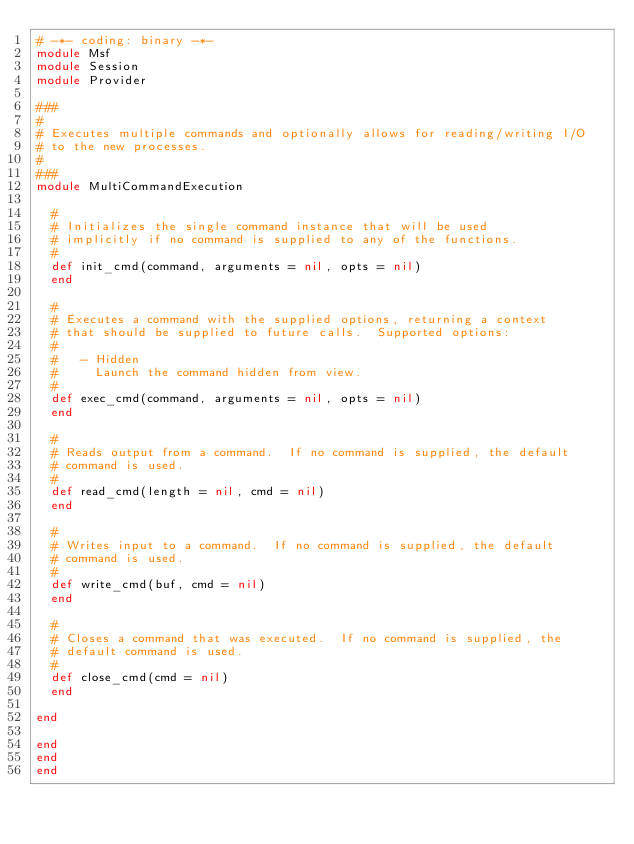<code> <loc_0><loc_0><loc_500><loc_500><_Ruby_># -*- coding: binary -*-
module Msf
module Session
module Provider

###
#
# Executes multiple commands and optionally allows for reading/writing I/O
# to the new processes.
#
###
module MultiCommandExecution

  #
  # Initializes the single command instance that will be used
  # implicitly if no command is supplied to any of the functions.
  #
  def init_cmd(command, arguments = nil, opts = nil)
  end

  #
  # Executes a command with the supplied options, returning a context
  # that should be supplied to future calls.  Supported options:
  #
  #   - Hidden
  #     Launch the command hidden from view.
  #
  def exec_cmd(command, arguments = nil, opts = nil)
  end

  #
  # Reads output from a command.  If no command is supplied, the default
  # command is used.
  #
  def read_cmd(length = nil, cmd = nil)
  end

  #
  # Writes input to a command.  If no command is supplied, the default
  # command is used.
  #
  def write_cmd(buf, cmd = nil)
  end

  #
  # Closes a command that was executed.  If no command is supplied, the
  # default command is used.
  #
  def close_cmd(cmd = nil)
  end

end

end
end
end
</code> 